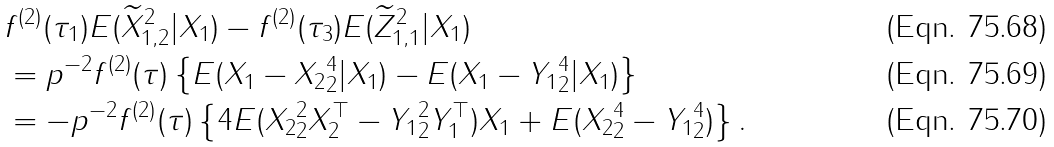Convert formula to latex. <formula><loc_0><loc_0><loc_500><loc_500>& f ^ { ( 2 ) } ( \tau _ { 1 } ) E ( \widetilde { X } _ { 1 , 2 } ^ { 2 } | X _ { 1 } ) - f ^ { ( 2 ) } ( \tau _ { 3 } ) E ( \widetilde { Z } _ { 1 , 1 } ^ { 2 } | X _ { 1 } ) \\ & = p ^ { - 2 } f ^ { ( 2 ) } ( \tau ) \left \{ E ( \| X _ { 1 } - X _ { 2 } \| _ { 2 } ^ { 4 } | X _ { 1 } ) - E ( \| X _ { 1 } - Y _ { 1 } \| _ { 2 } ^ { 4 } | X _ { 1 } ) \right \} \\ & = - p ^ { - 2 } f ^ { ( 2 ) } ( \tau ) \left \{ 4 E ( \| X _ { 2 } \| _ { 2 } ^ { 2 } X _ { 2 } ^ { \top } - \| Y _ { 1 } \| _ { 2 } ^ { 2 } Y _ { 1 } ^ { \top } ) X _ { 1 } + E ( \| X _ { 2 } \| _ { 2 } ^ { 4 } - \| Y _ { 1 } \| _ { 2 } ^ { 4 } ) \right \} .</formula> 